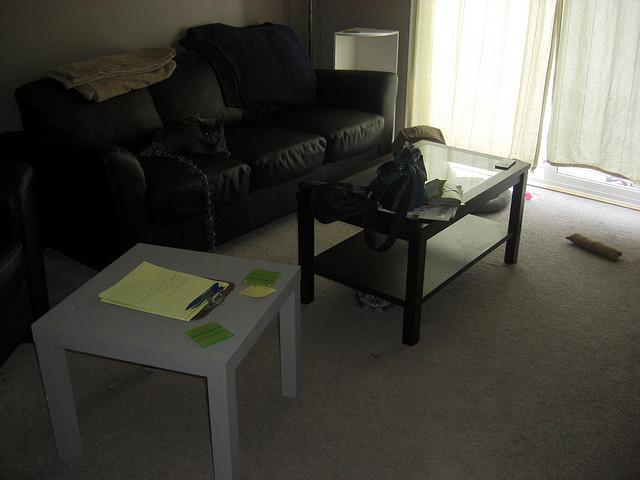What is the cat on the right sleeping on?
Give a very brief answer. Couch. Is there a mattress?
Answer briefly. No. Is this room dark or bright?
Keep it brief. Dark. Why is the room dark?
Concise answer only. No lights on. What color is the rug?
Write a very short answer. Gray. Whose room is this?
Write a very short answer. Living room. Is the floor carpeted?
Short answer required. Yes. What animal is blending in with the sofa?
Concise answer only. Cat. 